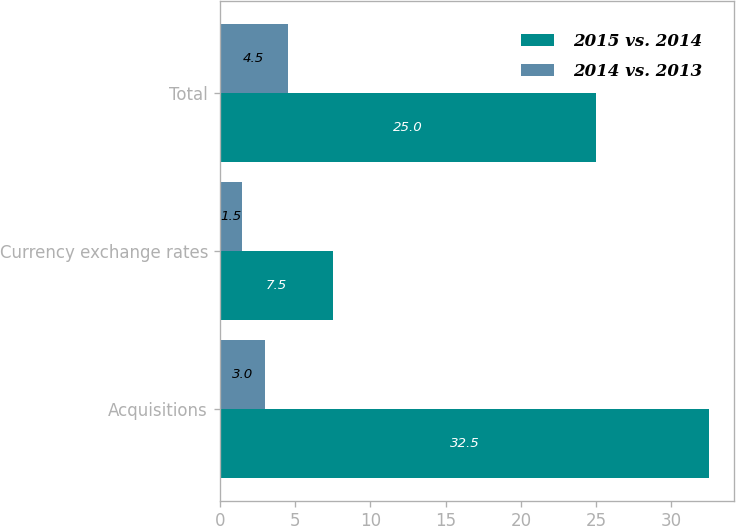Convert chart. <chart><loc_0><loc_0><loc_500><loc_500><stacked_bar_chart><ecel><fcel>Acquisitions<fcel>Currency exchange rates<fcel>Total<nl><fcel>2015 vs. 2014<fcel>32.5<fcel>7.5<fcel>25<nl><fcel>2014 vs. 2013<fcel>3<fcel>1.5<fcel>4.5<nl></chart> 